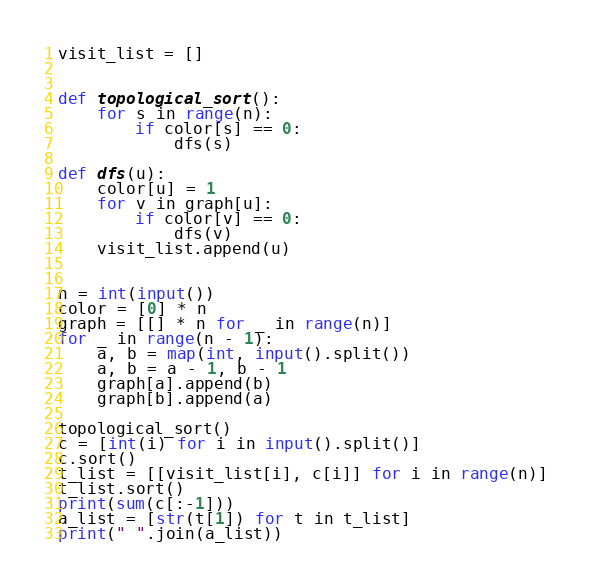<code> <loc_0><loc_0><loc_500><loc_500><_Python_>visit_list = []


def topological_sort():
    for s in range(n):
        if color[s] == 0:
            dfs(s)

def dfs(u):
    color[u] = 1
    for v in graph[u]:
        if color[v] == 0:
            dfs(v)
    visit_list.append(u)        
 
 
n = int(input())
color = [0] * n
graph = [[] * n for _ in range(n)]
for _ in range(n - 1):
    a, b = map(int, input().split())
    a, b = a - 1, b - 1
    graph[a].append(b)
    graph[b].append(a)    

topological_sort()
c = [int(i) for i in input().split()]
c.sort()
t_list = [[visit_list[i], c[i]] for i in range(n)]
t_list.sort()
print(sum(c[:-1]))
a_list = [str(t[1]) for t in t_list]
print(" ".join(a_list))</code> 